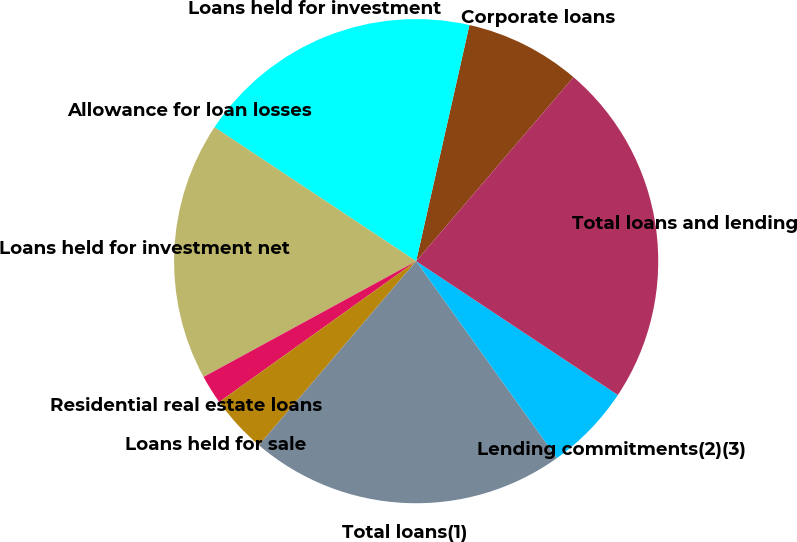Convert chart to OTSL. <chart><loc_0><loc_0><loc_500><loc_500><pie_chart><fcel>Corporate loans<fcel>Loans held for investment<fcel>Allowance for loan losses<fcel>Loans held for investment net<fcel>Residential real estate loans<fcel>Loans held for sale<fcel>Total loans(1)<fcel>Lending commitments(2)(3)<fcel>Total loans and lending<nl><fcel>7.73%<fcel>19.2%<fcel>0.01%<fcel>17.26%<fcel>1.94%<fcel>3.87%<fcel>21.13%<fcel>5.8%<fcel>23.06%<nl></chart> 